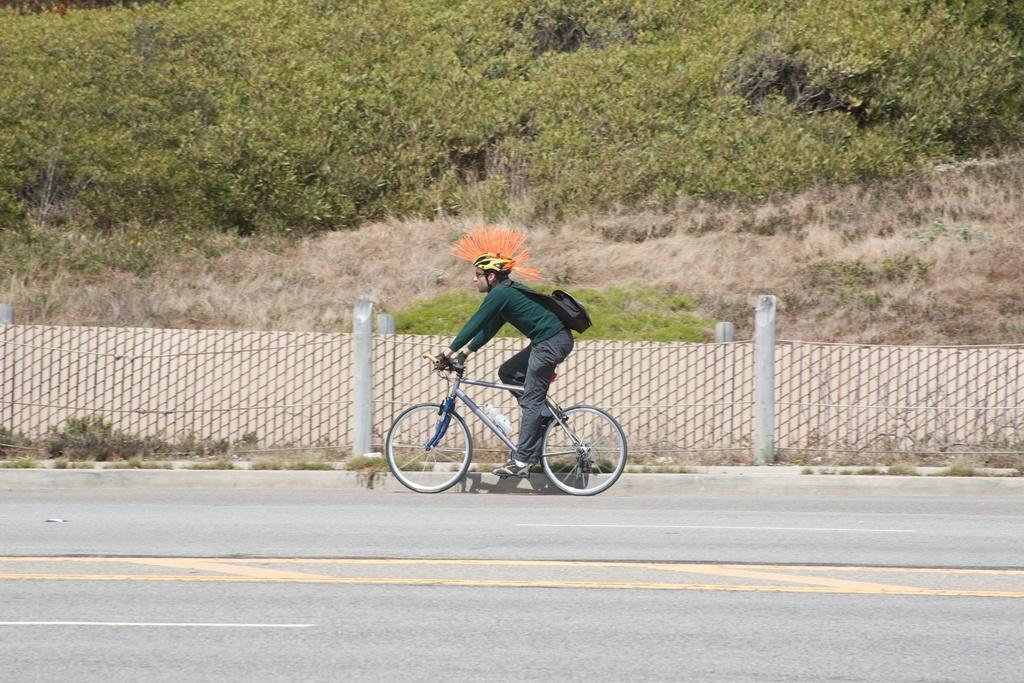Who is the main subject in the image? There is a boy in the center of the image. What is the boy doing in the image? The boy is on a bicycle. What can be seen in the middle of the image? There is a boundary in the center of the image. What type of vegetation is visible at the top side of the image? There are trees at the top side of the image. What type of pest can be seen crawling on the boy's bicycle in the image? There are no pests visible on the boy's bicycle in the image. What type of joke is the boy telling while riding the bicycle in the image? There is no indication of a joke being told in the image; the boy is simply riding a bicycle. 